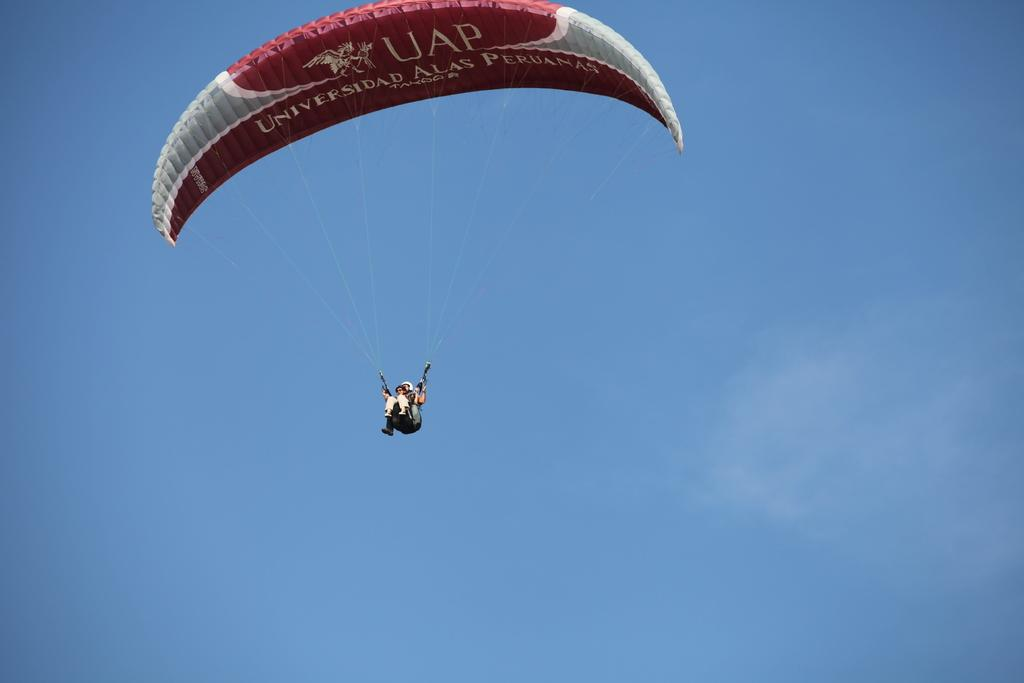How many people are in the image? There are two persons in the image. What else can be seen in the image besides the people? There are wires, the sky, a parachute, and text or writing present in the image. What might the parachute be used for? The parachute might be used for slowing down a descent or for recreational purposes. Can you describe the text or writing in the image? Unfortunately, without more information about the content or language of the text, it is difficult to provide a detailed description. What type of jeans is the beast wearing in the image? There is no beast present in the image, and therefore no jeans to describe. 